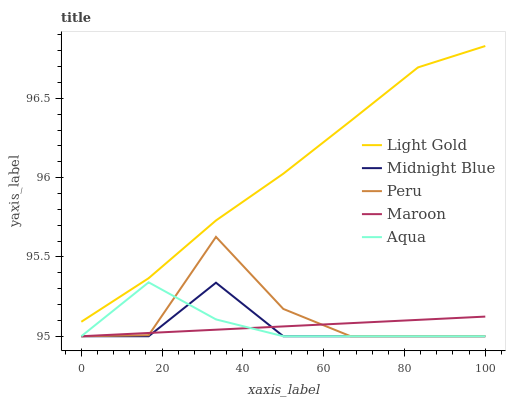Does Midnight Blue have the minimum area under the curve?
Answer yes or no. Yes. Does Light Gold have the maximum area under the curve?
Answer yes or no. Yes. Does Maroon have the minimum area under the curve?
Answer yes or no. No. Does Maroon have the maximum area under the curve?
Answer yes or no. No. Is Maroon the smoothest?
Answer yes or no. Yes. Is Peru the roughest?
Answer yes or no. Yes. Is Light Gold the smoothest?
Answer yes or no. No. Is Light Gold the roughest?
Answer yes or no. No. Does Aqua have the lowest value?
Answer yes or no. Yes. Does Light Gold have the lowest value?
Answer yes or no. No. Does Light Gold have the highest value?
Answer yes or no. Yes. Does Maroon have the highest value?
Answer yes or no. No. Is Maroon less than Light Gold?
Answer yes or no. Yes. Is Light Gold greater than Peru?
Answer yes or no. Yes. Does Peru intersect Maroon?
Answer yes or no. Yes. Is Peru less than Maroon?
Answer yes or no. No. Is Peru greater than Maroon?
Answer yes or no. No. Does Maroon intersect Light Gold?
Answer yes or no. No. 